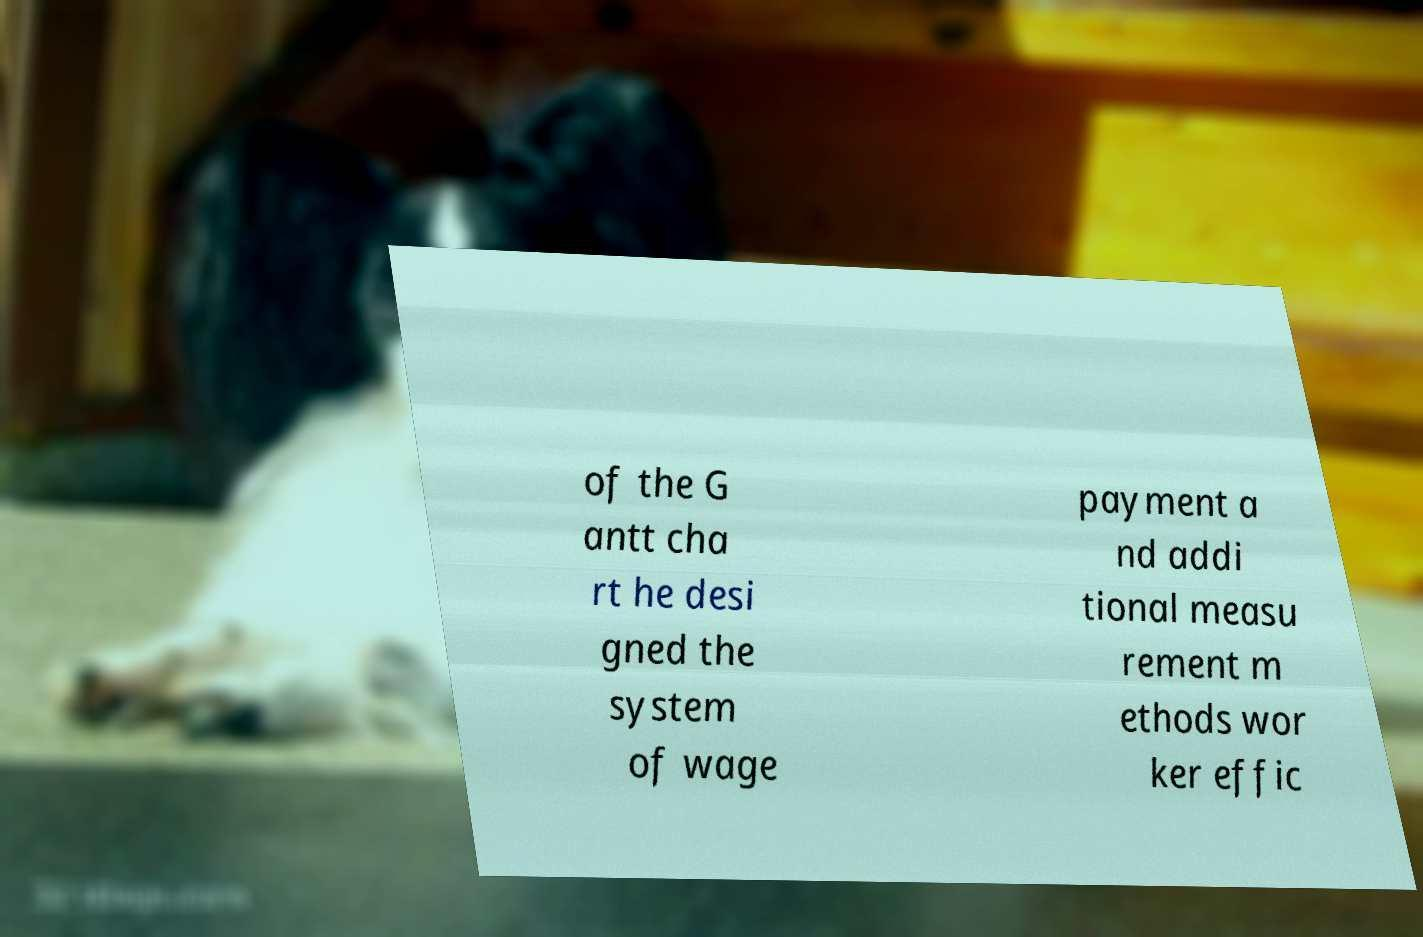Please identify and transcribe the text found in this image. of the G antt cha rt he desi gned the system of wage payment a nd addi tional measu rement m ethods wor ker effic 